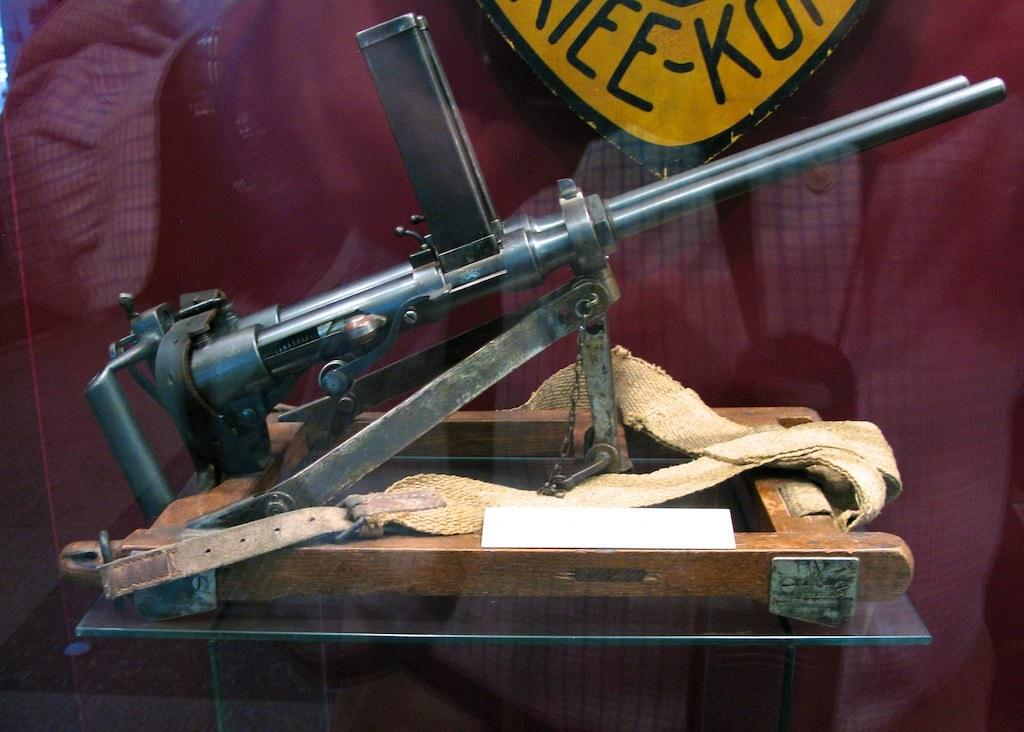What object is the main focus of the image? There is a gun in the image. How is the gun secured or held in place? The gun is tied with belts. What other objects are present in the image? The gun is placed in between glasses. Where is the toothbrush placed in the image? There is no toothbrush present in the image. What type of patch is covering the gun in the image? There is no patch covering the gun in the image; it is tied with belts. 